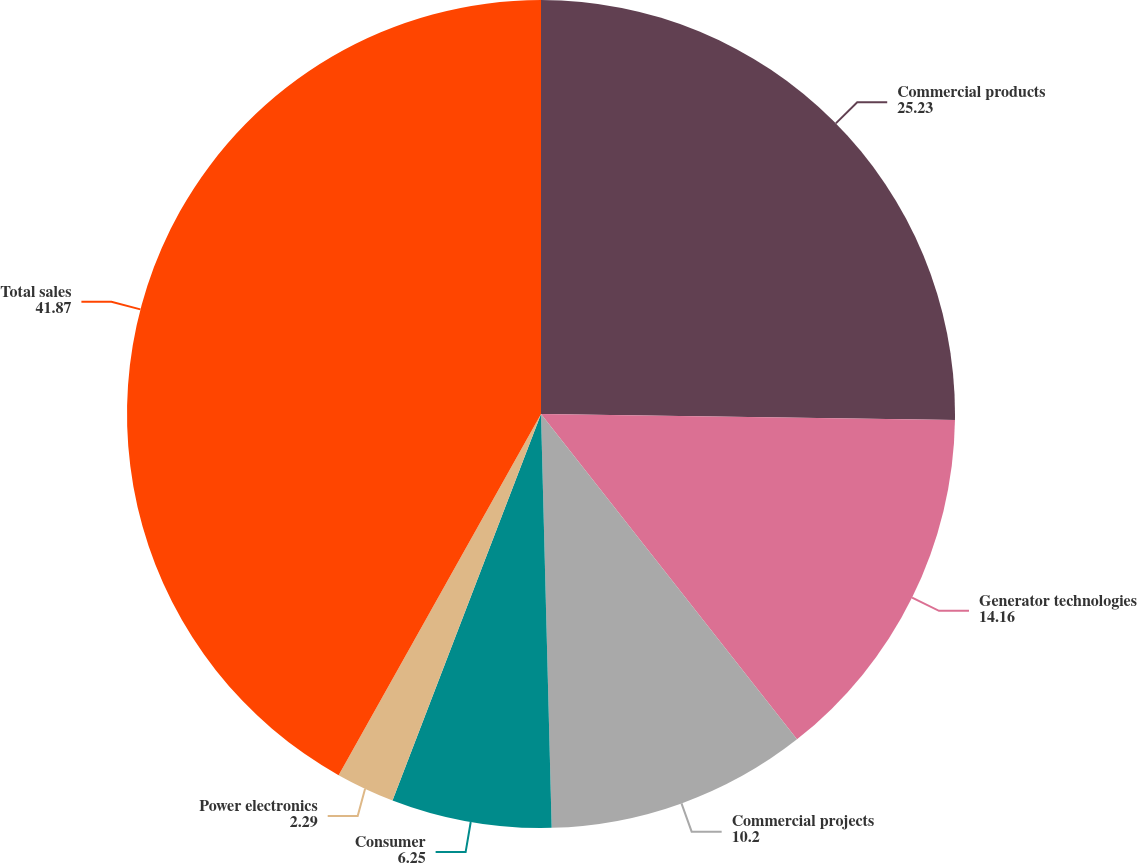<chart> <loc_0><loc_0><loc_500><loc_500><pie_chart><fcel>Commercial products<fcel>Generator technologies<fcel>Commercial projects<fcel>Consumer<fcel>Power electronics<fcel>Total sales<nl><fcel>25.23%<fcel>14.16%<fcel>10.2%<fcel>6.25%<fcel>2.29%<fcel>41.87%<nl></chart> 